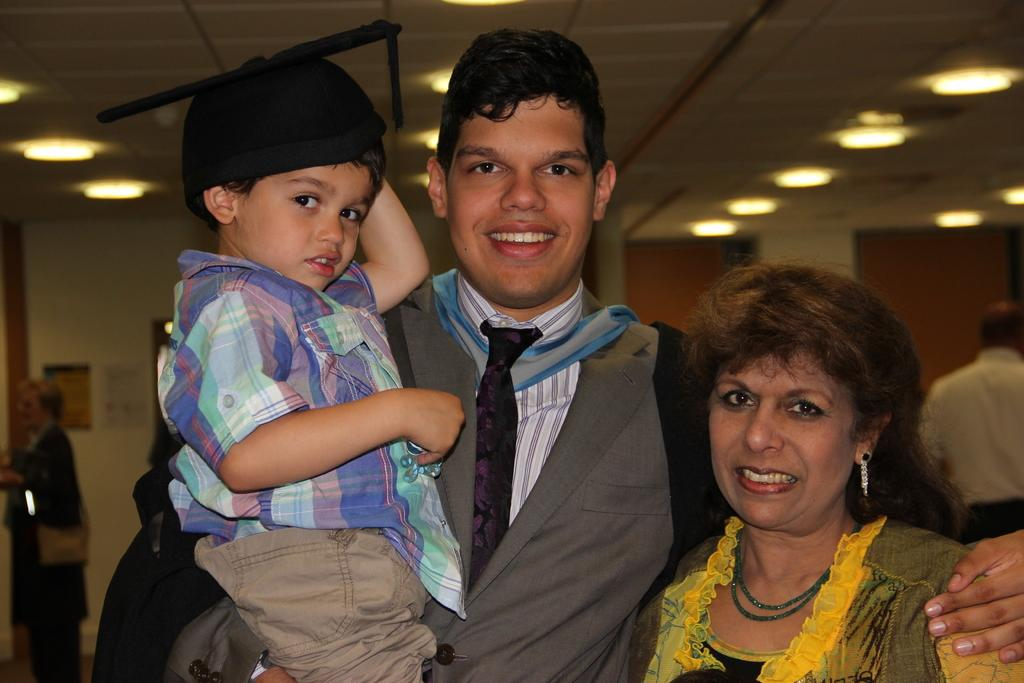How many people are in the image? There are two people in the image, a man and a woman. What is the man doing in the image? The man is holding a boy's hand in the image. What is present on the roof in the image? There are lights present on the roof in the image. Can you describe the people in the image? There are a man, a woman, and a boy present in the image. What type of oranges can be seen in the image? There are no oranges present in the image. What is the front of the room like in the image? There is no room present in the image, only a man, a woman, and a boy. 